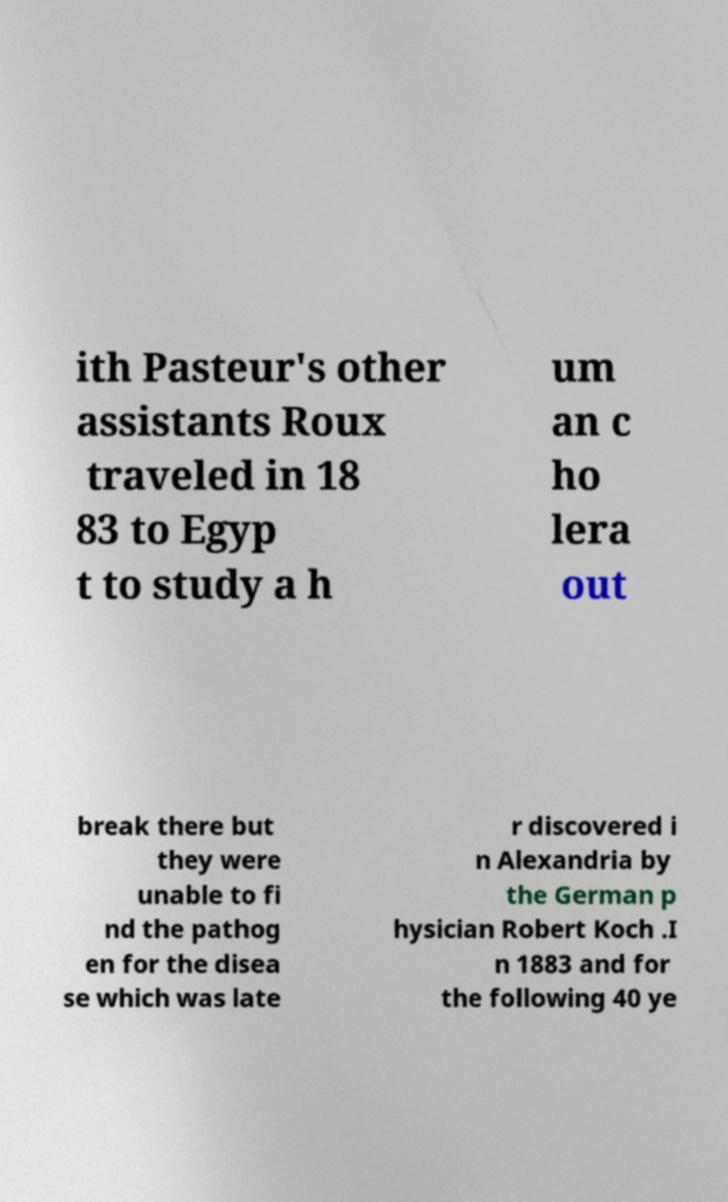There's text embedded in this image that I need extracted. Can you transcribe it verbatim? ith Pasteur's other assistants Roux traveled in 18 83 to Egyp t to study a h um an c ho lera out break there but they were unable to fi nd the pathog en for the disea se which was late r discovered i n Alexandria by the German p hysician Robert Koch .I n 1883 and for the following 40 ye 